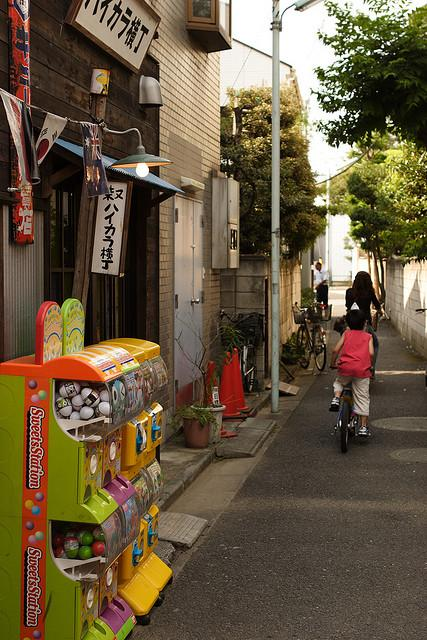What are the colorful machines called? Please explain your reasoning. vending machines. These machines give out something when you put money into them. 